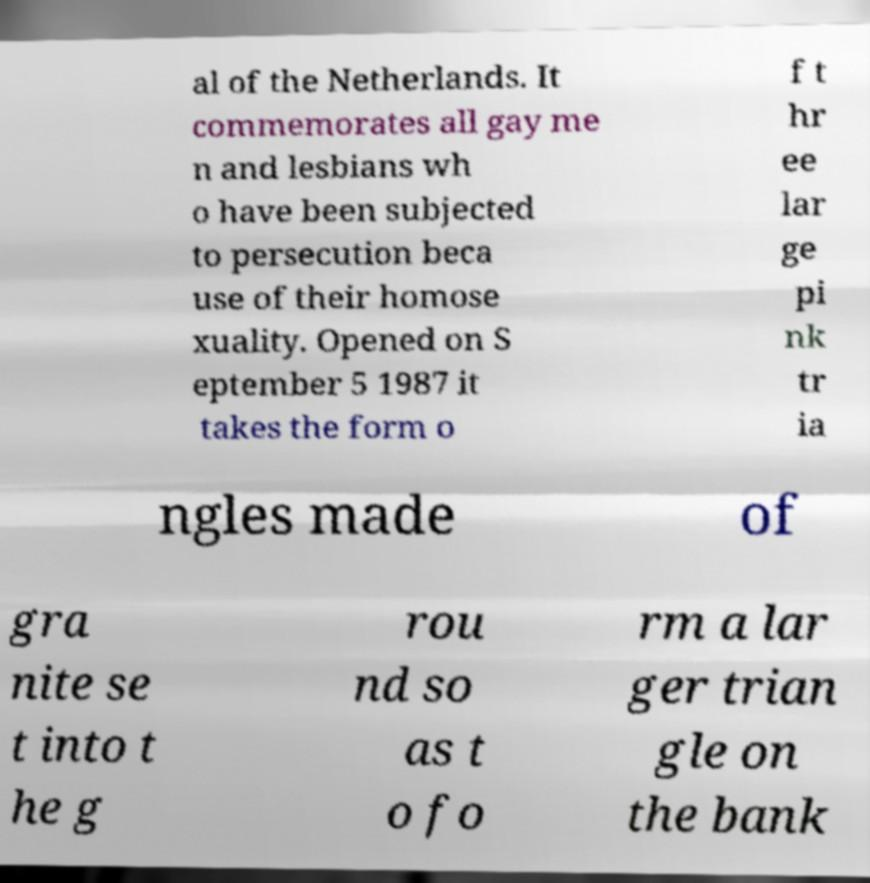For documentation purposes, I need the text within this image transcribed. Could you provide that? al of the Netherlands. It commemorates all gay me n and lesbians wh o have been subjected to persecution beca use of their homose xuality. Opened on S eptember 5 1987 it takes the form o f t hr ee lar ge pi nk tr ia ngles made of gra nite se t into t he g rou nd so as t o fo rm a lar ger trian gle on the bank 